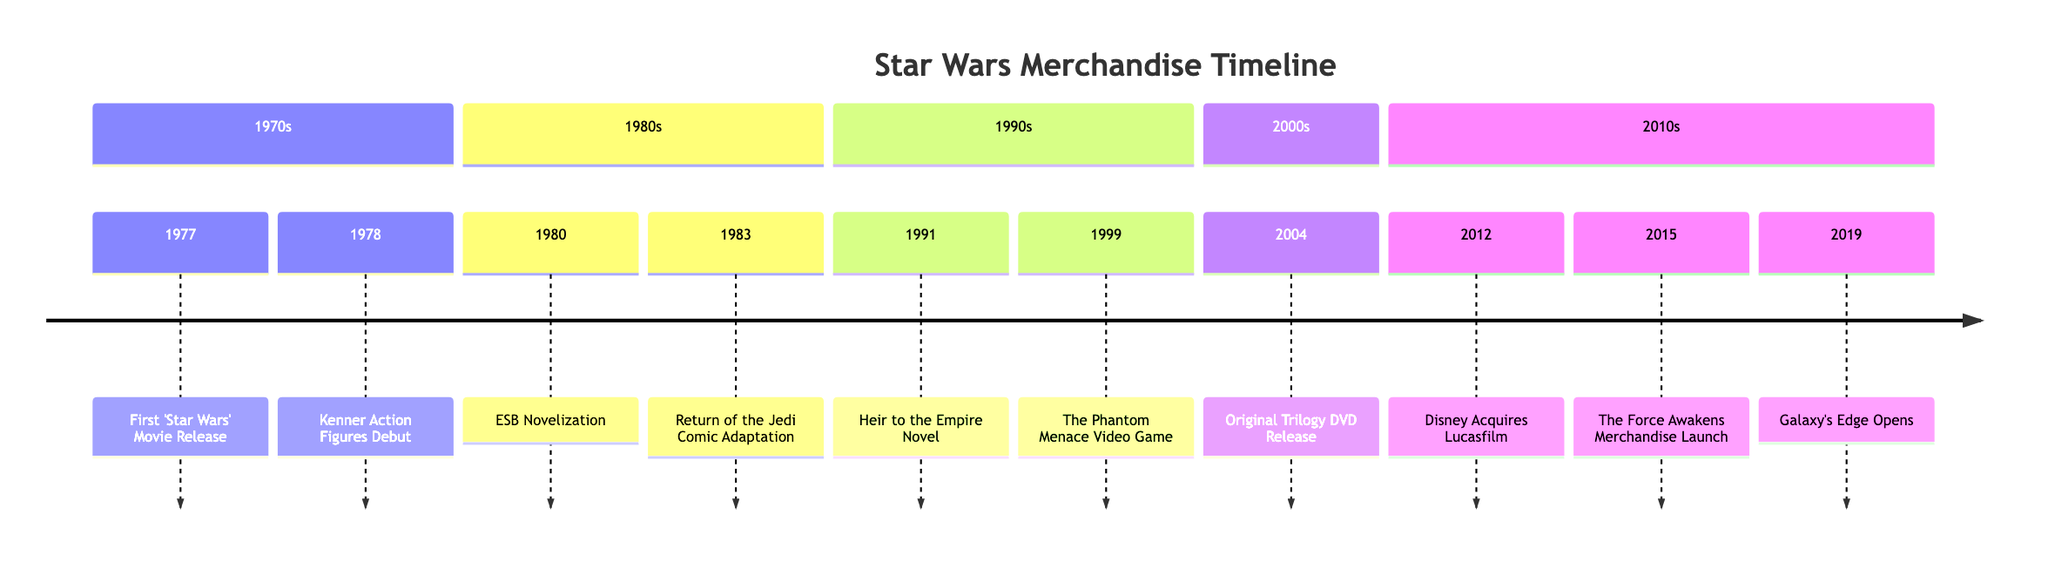What event occurred in 1977? The timeline shows that in 1977, the first 'Star Wars' movie was released, marking the beginning of the franchise.
Answer: First 'Star Wars' Movie Release How many years passed between the release of the first 'Star Wars' movie and the debut of Kenner action figures? The first 'Star Wars' movie was released in 1977, and Kenner action figures debuted in 1978. Therefore, only 1 year passed between these two events.
Answer: 1 year What event is associated with the year 1999? According to the timeline, the event associated with 1999 is the release of 'Star Wars Episode I: The Phantom Menace' video game, timed with the movie release.
Answer: The Phantom Menace Video Game What significant corporate change happened in 2012? The timeline indicates that in 2012, Disney acquired Lucasfilm, which was a major change for the franchise.
Answer: Disney Acquires Lucasfilm Which decade saw the publication of both the ESB novelization and the Return of the Jedi comic adaptation? The timeline shows both the ESB novelization and the Return of the Jedi comic adaptation occurred in the 1980s.
Answer: 1980s What merchandise was launched with 'Star Wars: The Force Awakens' in 2015? In 2015, the timeline notes the launch of a new wave of merchandise including toys, apparel, and collectibles, coinciding with the release of 'Star Wars: The Force Awakens.'
Answer: Merchandise How many events took place in the 2000s according to the timeline? The timeline lists one event that took place in the 2000s, which is the original trilogy DVD release in 2004.
Answer: 1 event When did Star Wars: Galaxy's Edge open? The timeline indicates that Star Wars: Galaxy's Edge opened in 2019.
Answer: 2019 Which event represents a significant expansion into the gaming industry? The timeline details that the release of 'Star Wars Episode I: The Phantom Menace' video game in 1999 marks a significant expansion into the gaming industry for 'Star Wars.'
Answer: The Phantom Menace Video Game 